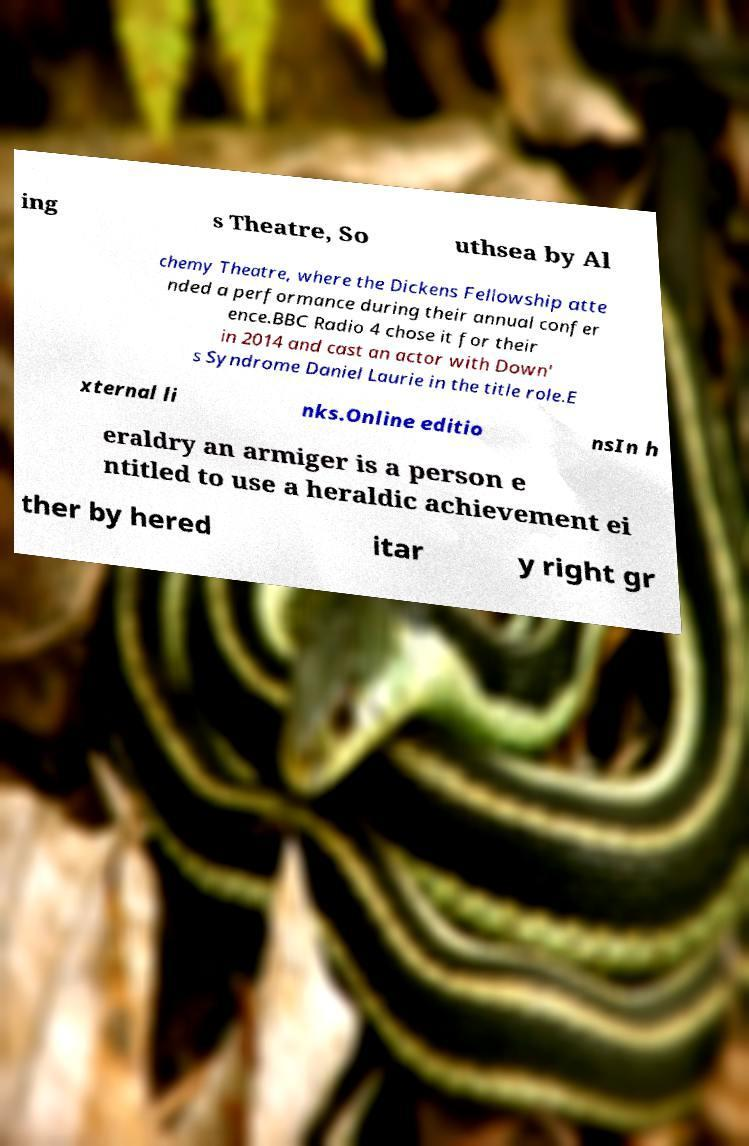What messages or text are displayed in this image? I need them in a readable, typed format. ing s Theatre, So uthsea by Al chemy Theatre, where the Dickens Fellowship atte nded a performance during their annual confer ence.BBC Radio 4 chose it for their in 2014 and cast an actor with Down' s Syndrome Daniel Laurie in the title role.E xternal li nks.Online editio nsIn h eraldry an armiger is a person e ntitled to use a heraldic achievement ei ther by hered itar y right gr 